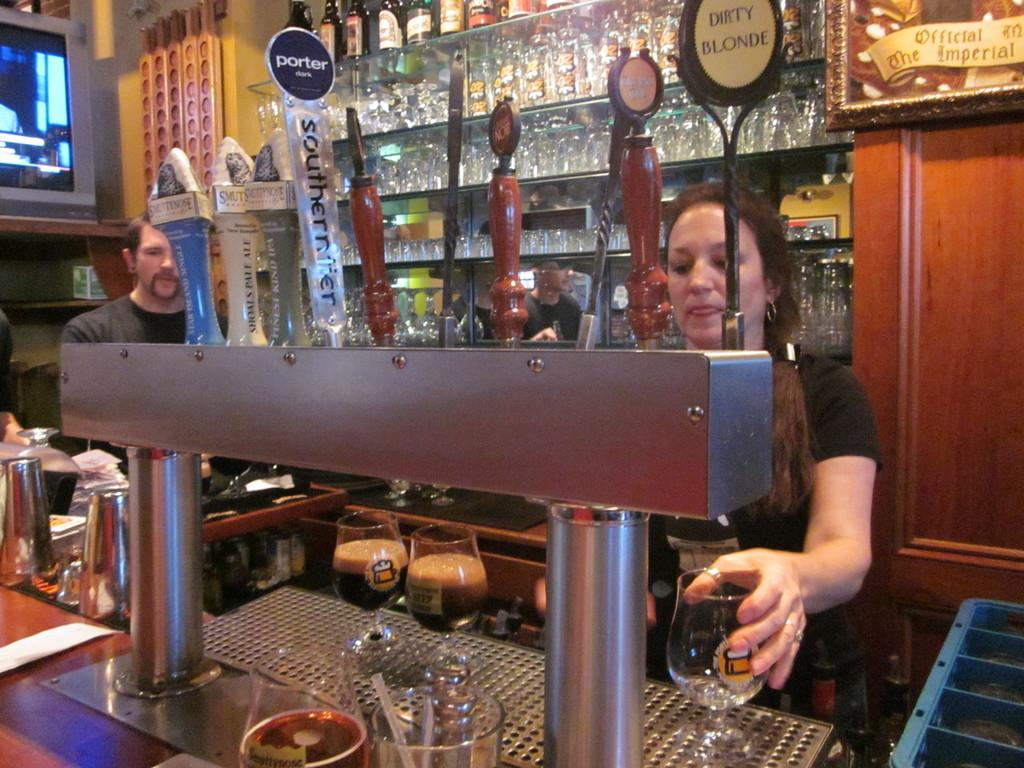Provide a one-sentence caption for the provided image. a view of a bar worker pulling beers like Porter dark and Dirty Blonde. 